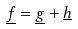<formula> <loc_0><loc_0><loc_500><loc_500>\underline { f } = \underline { g } + \underline { h }</formula> 